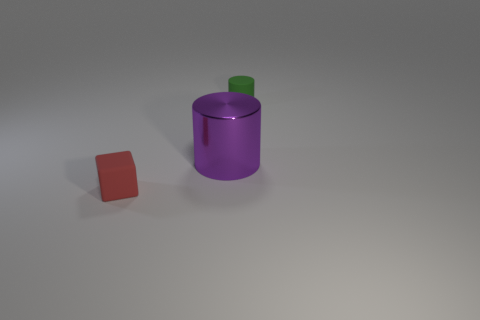Is there a small red rubber block behind the cylinder that is left of the tiny rubber thing right of the rubber block?
Keep it short and to the point. No. Do the block and the purple object have the same size?
Your response must be concise. No. Are there an equal number of tiny green matte things that are to the left of the matte cube and green things in front of the small green rubber cylinder?
Your response must be concise. Yes. There is a rubber thing that is on the right side of the small red object; what is its shape?
Your response must be concise. Cylinder. There is another matte object that is the same size as the green object; what shape is it?
Make the answer very short. Cube. What color is the tiny object that is left of the green thing to the right of the matte object that is left of the small green cylinder?
Your answer should be very brief. Red. Does the tiny red object have the same shape as the green matte thing?
Keep it short and to the point. No. Are there an equal number of cylinders left of the purple thing and yellow rubber things?
Your response must be concise. Yes. How many other things are the same material as the tiny red cube?
Your response must be concise. 1. Is the size of the matte thing that is on the right side of the small red rubber block the same as the cylinder in front of the small matte cylinder?
Provide a short and direct response. No. 